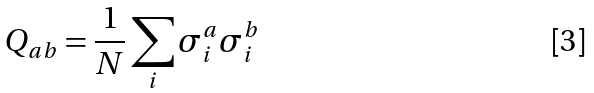Convert formula to latex. <formula><loc_0><loc_0><loc_500><loc_500>Q _ { a b } = \frac { 1 } { N } \sum _ { i } \sigma _ { i } ^ { a } \sigma _ { i } ^ { b }</formula> 